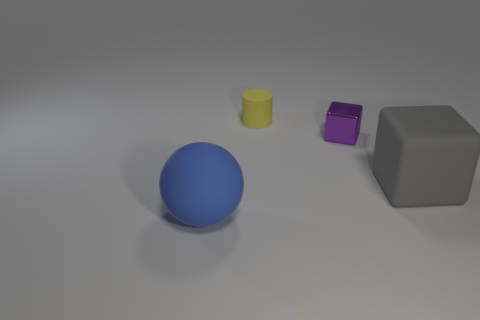What number of tiny objects are in front of the rubber object that is right of the small matte cylinder?
Offer a terse response. 0. What shape is the large thing that is to the left of the large object behind the object that is in front of the large gray thing?
Offer a very short reply. Sphere. How many objects are gray blocks or tiny cylinders?
Provide a short and direct response. 2. There is a cylinder that is the same size as the purple block; what color is it?
Make the answer very short. Yellow. Does the tiny purple metallic object have the same shape as the big rubber object that is on the right side of the matte ball?
Your answer should be very brief. Yes. What number of objects are things that are on the right side of the tiny yellow rubber object or things that are in front of the yellow cylinder?
Provide a short and direct response. 3. What is the shape of the matte thing behind the big gray matte cube?
Offer a terse response. Cylinder. Does the matte object that is in front of the large gray cube have the same shape as the large gray thing?
Offer a terse response. No. How many objects are large rubber things on the right side of the blue ball or small purple blocks?
Offer a terse response. 2. The other thing that is the same shape as the small purple thing is what color?
Offer a terse response. Gray. 